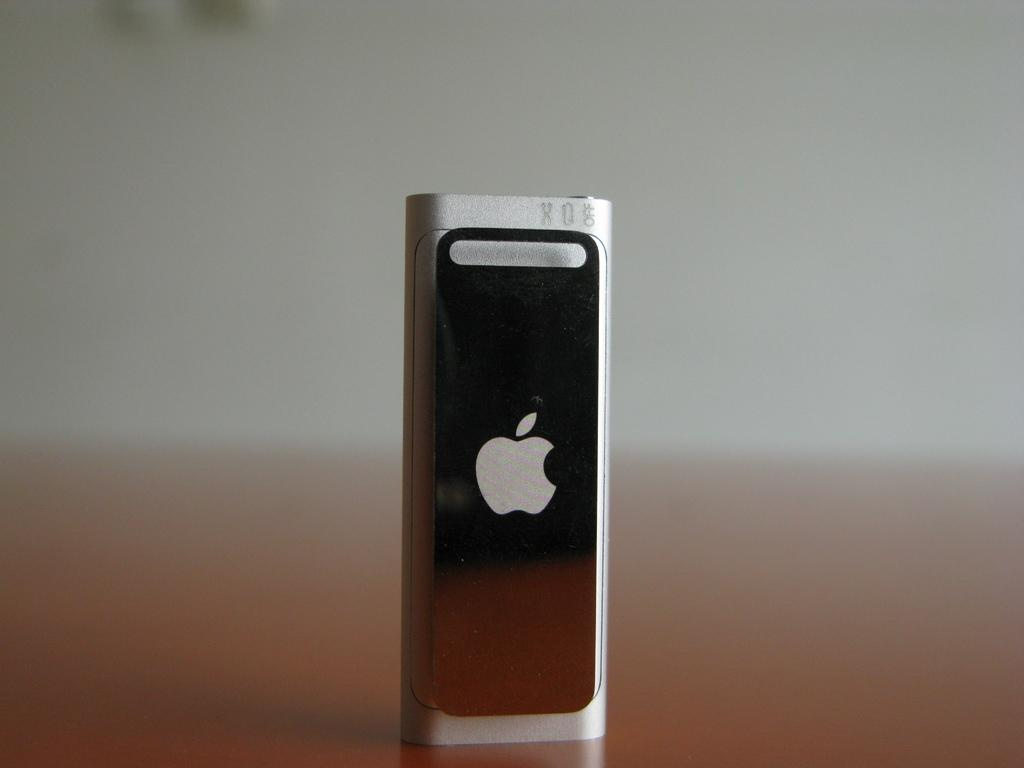What is the main object in the image? There is a device in the image. Can you describe any identifying features of the device? The device has a logo. Where is the device located in the image? The device is placed on a surface. How does the device kick the bubble in the image? There is no bubble present in the image, and therefore no such interaction can be observed. 